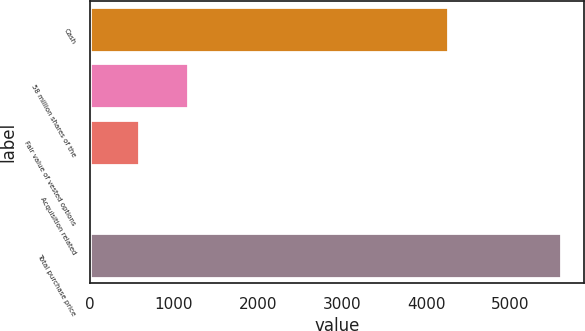<chart> <loc_0><loc_0><loc_500><loc_500><bar_chart><fcel>Cash<fcel>58 million shares of the<fcel>Fair value of vested options<fcel>Acquisition related<fcel>Total purchase price<nl><fcel>4263<fcel>1172<fcel>582.9<fcel>25<fcel>5604<nl></chart> 